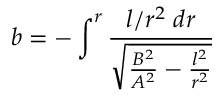Convert formula to latex. <formula><loc_0><loc_0><loc_500><loc_500>b = - \int ^ { r } \frac { l / r ^ { 2 } \, d r } { \sqrt { \frac { B ^ { 2 } } { A ^ { 2 } } - \frac { l ^ { 2 } } { r ^ { 2 } } } }</formula> 